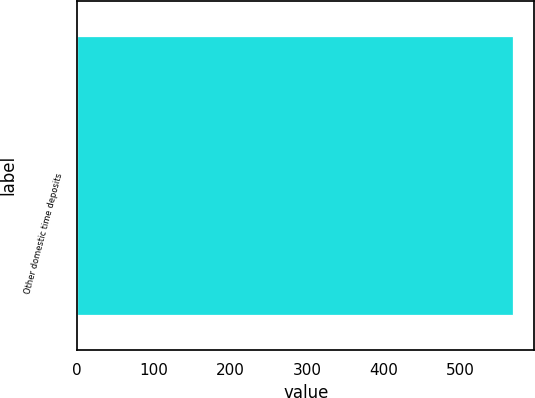<chart> <loc_0><loc_0><loc_500><loc_500><bar_chart><fcel>Other domestic time deposits<nl><fcel>568<nl></chart> 